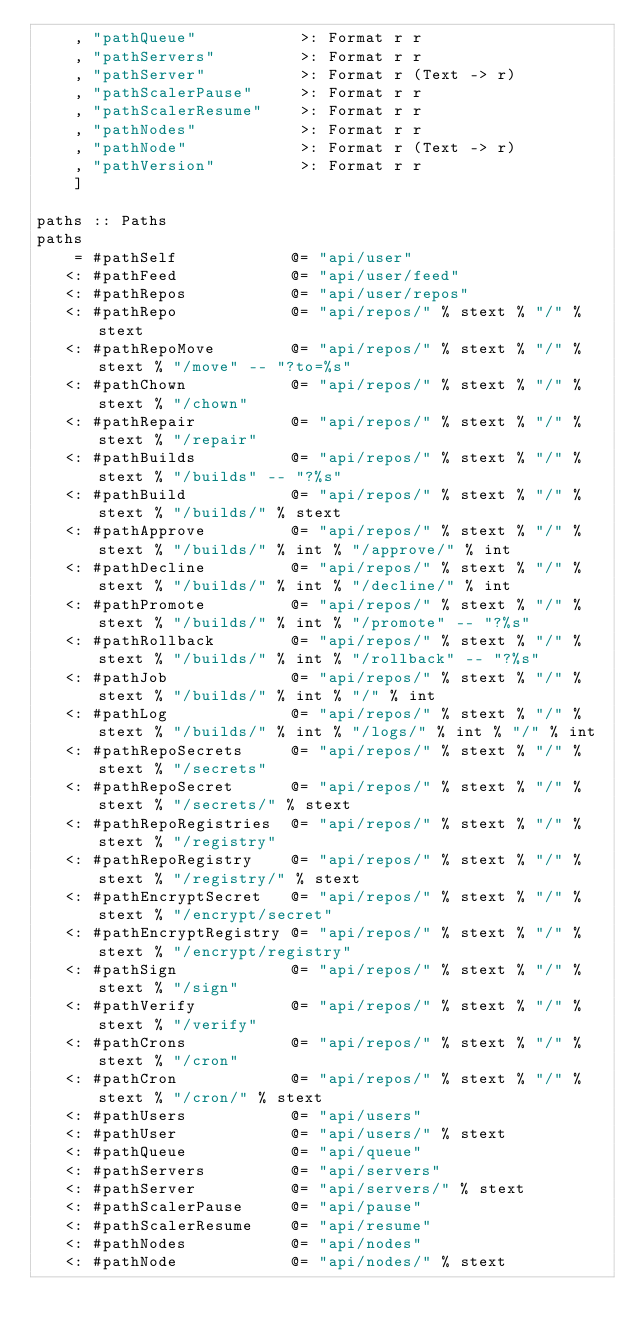<code> <loc_0><loc_0><loc_500><loc_500><_Haskell_>    , "pathQueue"           >: Format r r
    , "pathServers"         >: Format r r
    , "pathServer"          >: Format r (Text -> r)
    , "pathScalerPause"     >: Format r r
    , "pathScalerResume"    >: Format r r
    , "pathNodes"           >: Format r r
    , "pathNode"            >: Format r (Text -> r)
    , "pathVersion"         >: Format r r
    ]

paths :: Paths
paths
    = #pathSelf            @= "api/user"
   <: #pathFeed            @= "api/user/feed"
   <: #pathRepos           @= "api/user/repos"
   <: #pathRepo            @= "api/repos/" % stext % "/" % stext
   <: #pathRepoMove        @= "api/repos/" % stext % "/" % stext % "/move" -- "?to=%s"
   <: #pathChown           @= "api/repos/" % stext % "/" % stext % "/chown"
   <: #pathRepair          @= "api/repos/" % stext % "/" % stext % "/repair"
   <: #pathBuilds          @= "api/repos/" % stext % "/" % stext % "/builds" -- "?%s"
   <: #pathBuild           @= "api/repos/" % stext % "/" % stext % "/builds/" % stext
   <: #pathApprove         @= "api/repos/" % stext % "/" % stext % "/builds/" % int % "/approve/" % int
   <: #pathDecline         @= "api/repos/" % stext % "/" % stext % "/builds/" % int % "/decline/" % int
   <: #pathPromote         @= "api/repos/" % stext % "/" % stext % "/builds/" % int % "/promote" -- "?%s"
   <: #pathRollback        @= "api/repos/" % stext % "/" % stext % "/builds/" % int % "/rollback" -- "?%s"
   <: #pathJob             @= "api/repos/" % stext % "/" % stext % "/builds/" % int % "/" % int
   <: #pathLog             @= "api/repos/" % stext % "/" % stext % "/builds/" % int % "/logs/" % int % "/" % int
   <: #pathRepoSecrets     @= "api/repos/" % stext % "/" % stext % "/secrets"
   <: #pathRepoSecret      @= "api/repos/" % stext % "/" % stext % "/secrets/" % stext
   <: #pathRepoRegistries  @= "api/repos/" % stext % "/" % stext % "/registry"
   <: #pathRepoRegistry    @= "api/repos/" % stext % "/" % stext % "/registry/" % stext
   <: #pathEncryptSecret   @= "api/repos/" % stext % "/" % stext % "/encrypt/secret"
   <: #pathEncryptRegistry @= "api/repos/" % stext % "/" % stext % "/encrypt/registry"
   <: #pathSign            @= "api/repos/" % stext % "/" % stext % "/sign"
   <: #pathVerify          @= "api/repos/" % stext % "/" % stext % "/verify"
   <: #pathCrons           @= "api/repos/" % stext % "/" % stext % "/cron"
   <: #pathCron            @= "api/repos/" % stext % "/" % stext % "/cron/" % stext
   <: #pathUsers           @= "api/users"
   <: #pathUser            @= "api/users/" % stext
   <: #pathQueue           @= "api/queue"
   <: #pathServers         @= "api/servers"
   <: #pathServer          @= "api/servers/" % stext
   <: #pathScalerPause     @= "api/pause"
   <: #pathScalerResume    @= "api/resume"
   <: #pathNodes           @= "api/nodes"
   <: #pathNode            @= "api/nodes/" % stext</code> 